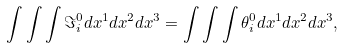<formula> <loc_0><loc_0><loc_500><loc_500>\int \int \int \Im _ { i } ^ { 0 } d x ^ { 1 } d x ^ { 2 } d x ^ { 3 } = \int \int \int \theta _ { i } ^ { 0 } d x ^ { 1 } d x ^ { 2 } d x ^ { 3 } ,</formula> 